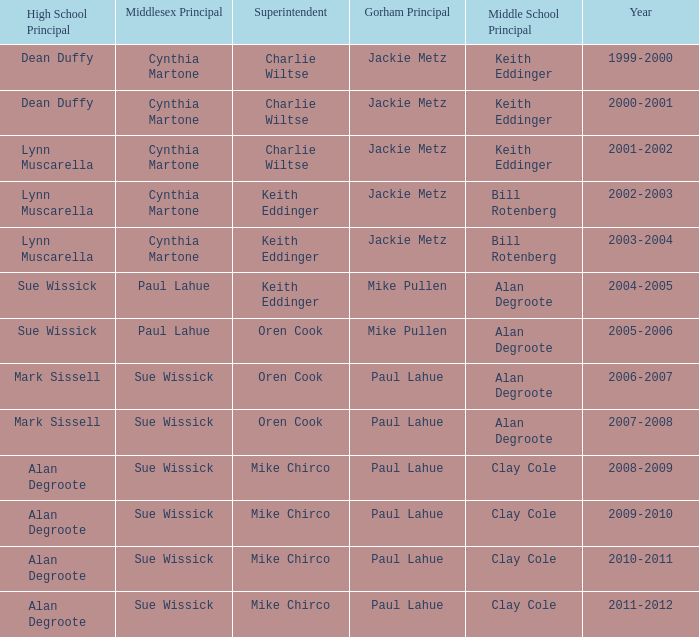How many years was lynn muscarella the high school principal and charlie wiltse the superintendent? 1.0. 